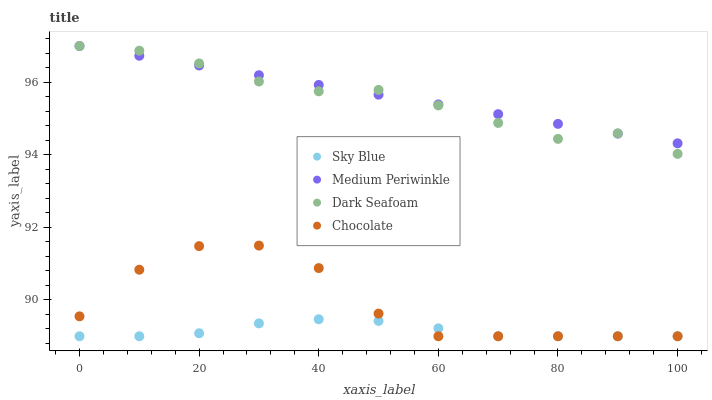Does Sky Blue have the minimum area under the curve?
Answer yes or no. Yes. Does Medium Periwinkle have the maximum area under the curve?
Answer yes or no. Yes. Does Dark Seafoam have the minimum area under the curve?
Answer yes or no. No. Does Dark Seafoam have the maximum area under the curve?
Answer yes or no. No. Is Medium Periwinkle the smoothest?
Answer yes or no. Yes. Is Chocolate the roughest?
Answer yes or no. Yes. Is Dark Seafoam the smoothest?
Answer yes or no. No. Is Dark Seafoam the roughest?
Answer yes or no. No. Does Sky Blue have the lowest value?
Answer yes or no. Yes. Does Dark Seafoam have the lowest value?
Answer yes or no. No. Does Medium Periwinkle have the highest value?
Answer yes or no. Yes. Does Chocolate have the highest value?
Answer yes or no. No. Is Chocolate less than Medium Periwinkle?
Answer yes or no. Yes. Is Medium Periwinkle greater than Chocolate?
Answer yes or no. Yes. Does Medium Periwinkle intersect Dark Seafoam?
Answer yes or no. Yes. Is Medium Periwinkle less than Dark Seafoam?
Answer yes or no. No. Is Medium Periwinkle greater than Dark Seafoam?
Answer yes or no. No. Does Chocolate intersect Medium Periwinkle?
Answer yes or no. No. 